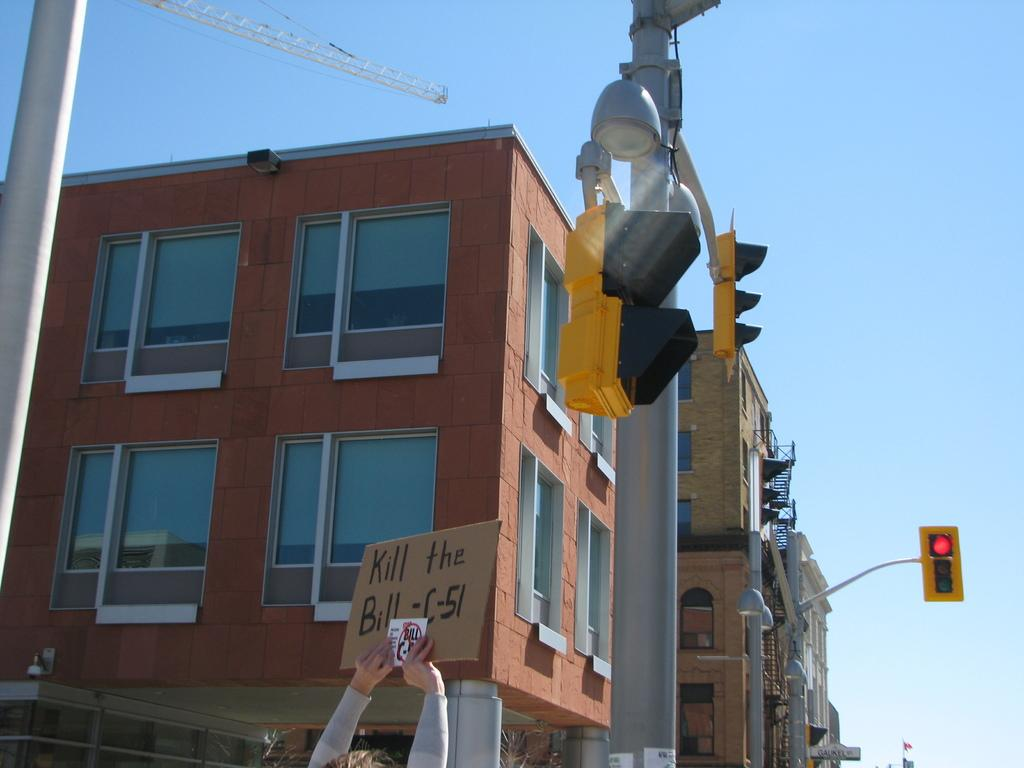<image>
Relay a brief, clear account of the picture shown. Someone is holding a sign that says "kill the bill C-51" 